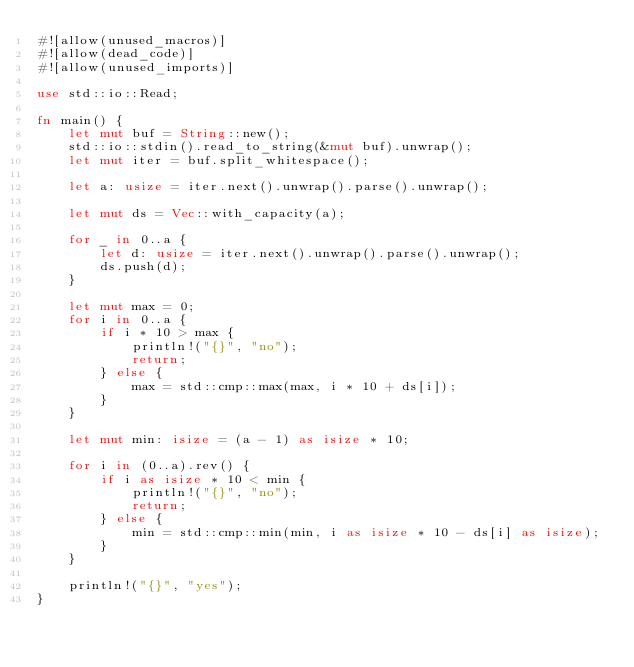<code> <loc_0><loc_0><loc_500><loc_500><_Rust_>#![allow(unused_macros)]
#![allow(dead_code)]
#![allow(unused_imports)]

use std::io::Read;

fn main() {
    let mut buf = String::new();
    std::io::stdin().read_to_string(&mut buf).unwrap();
    let mut iter = buf.split_whitespace();

    let a: usize = iter.next().unwrap().parse().unwrap();

    let mut ds = Vec::with_capacity(a);

    for _ in 0..a {
        let d: usize = iter.next().unwrap().parse().unwrap();
        ds.push(d);
    }

    let mut max = 0;
    for i in 0..a {
        if i * 10 > max {
            println!("{}", "no");
            return;
        } else {
            max = std::cmp::max(max, i * 10 + ds[i]);
        }
    }

    let mut min: isize = (a - 1) as isize * 10;

    for i in (0..a).rev() {
        if i as isize * 10 < min {
            println!("{}", "no");
            return;
        } else {
            min = std::cmp::min(min, i as isize * 10 - ds[i] as isize);
        }
    }

    println!("{}", "yes");
}

</code> 